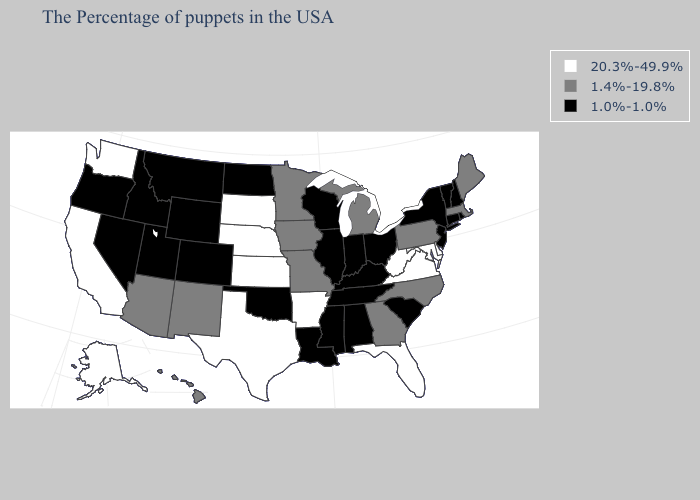Does Colorado have the same value as South Carolina?
Concise answer only. Yes. Which states hav the highest value in the Northeast?
Short answer required. Maine, Massachusetts, Pennsylvania. Does Virginia have the lowest value in the USA?
Write a very short answer. No. Does the first symbol in the legend represent the smallest category?
Concise answer only. No. What is the value of Georgia?
Quick response, please. 1.4%-19.8%. Name the states that have a value in the range 20.3%-49.9%?
Give a very brief answer. Delaware, Maryland, Virginia, West Virginia, Florida, Arkansas, Kansas, Nebraska, Texas, South Dakota, California, Washington, Alaska. Does Georgia have the lowest value in the USA?
Write a very short answer. No. What is the value of Rhode Island?
Be succinct. 1.0%-1.0%. Which states hav the highest value in the West?
Give a very brief answer. California, Washington, Alaska. Among the states that border Montana , does South Dakota have the highest value?
Write a very short answer. Yes. What is the value of Nevada?
Short answer required. 1.0%-1.0%. Which states have the lowest value in the Northeast?
Answer briefly. Rhode Island, New Hampshire, Vermont, Connecticut, New York, New Jersey. Among the states that border Kansas , which have the highest value?
Write a very short answer. Nebraska. Which states have the lowest value in the USA?
Write a very short answer. Rhode Island, New Hampshire, Vermont, Connecticut, New York, New Jersey, South Carolina, Ohio, Kentucky, Indiana, Alabama, Tennessee, Wisconsin, Illinois, Mississippi, Louisiana, Oklahoma, North Dakota, Wyoming, Colorado, Utah, Montana, Idaho, Nevada, Oregon. What is the value of Colorado?
Give a very brief answer. 1.0%-1.0%. 